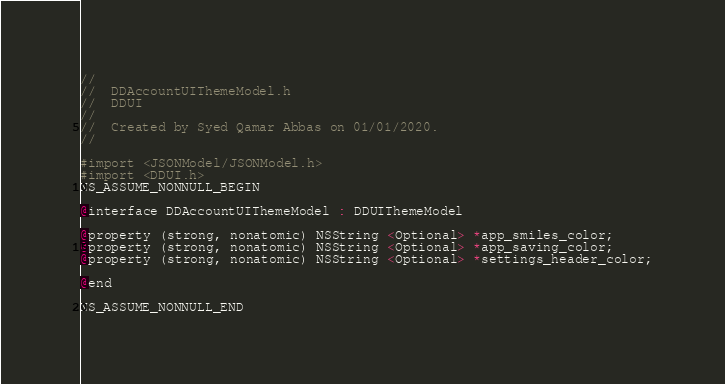Convert code to text. <code><loc_0><loc_0><loc_500><loc_500><_C_>//
//  DDAccountUIThemeModel.h
//  DDUI
//
//  Created by Syed Qamar Abbas on 01/01/2020.
//

#import <JSONModel/JSONModel.h>
#import <DDUI.h>
NS_ASSUME_NONNULL_BEGIN

@interface DDAccountUIThemeModel : DDUIThemeModel

@property (strong, nonatomic) NSString <Optional> *app_smiles_color;
@property (strong, nonatomic) NSString <Optional> *app_saving_color;
@property (strong, nonatomic) NSString <Optional> *settings_header_color;

@end

NS_ASSUME_NONNULL_END
</code> 